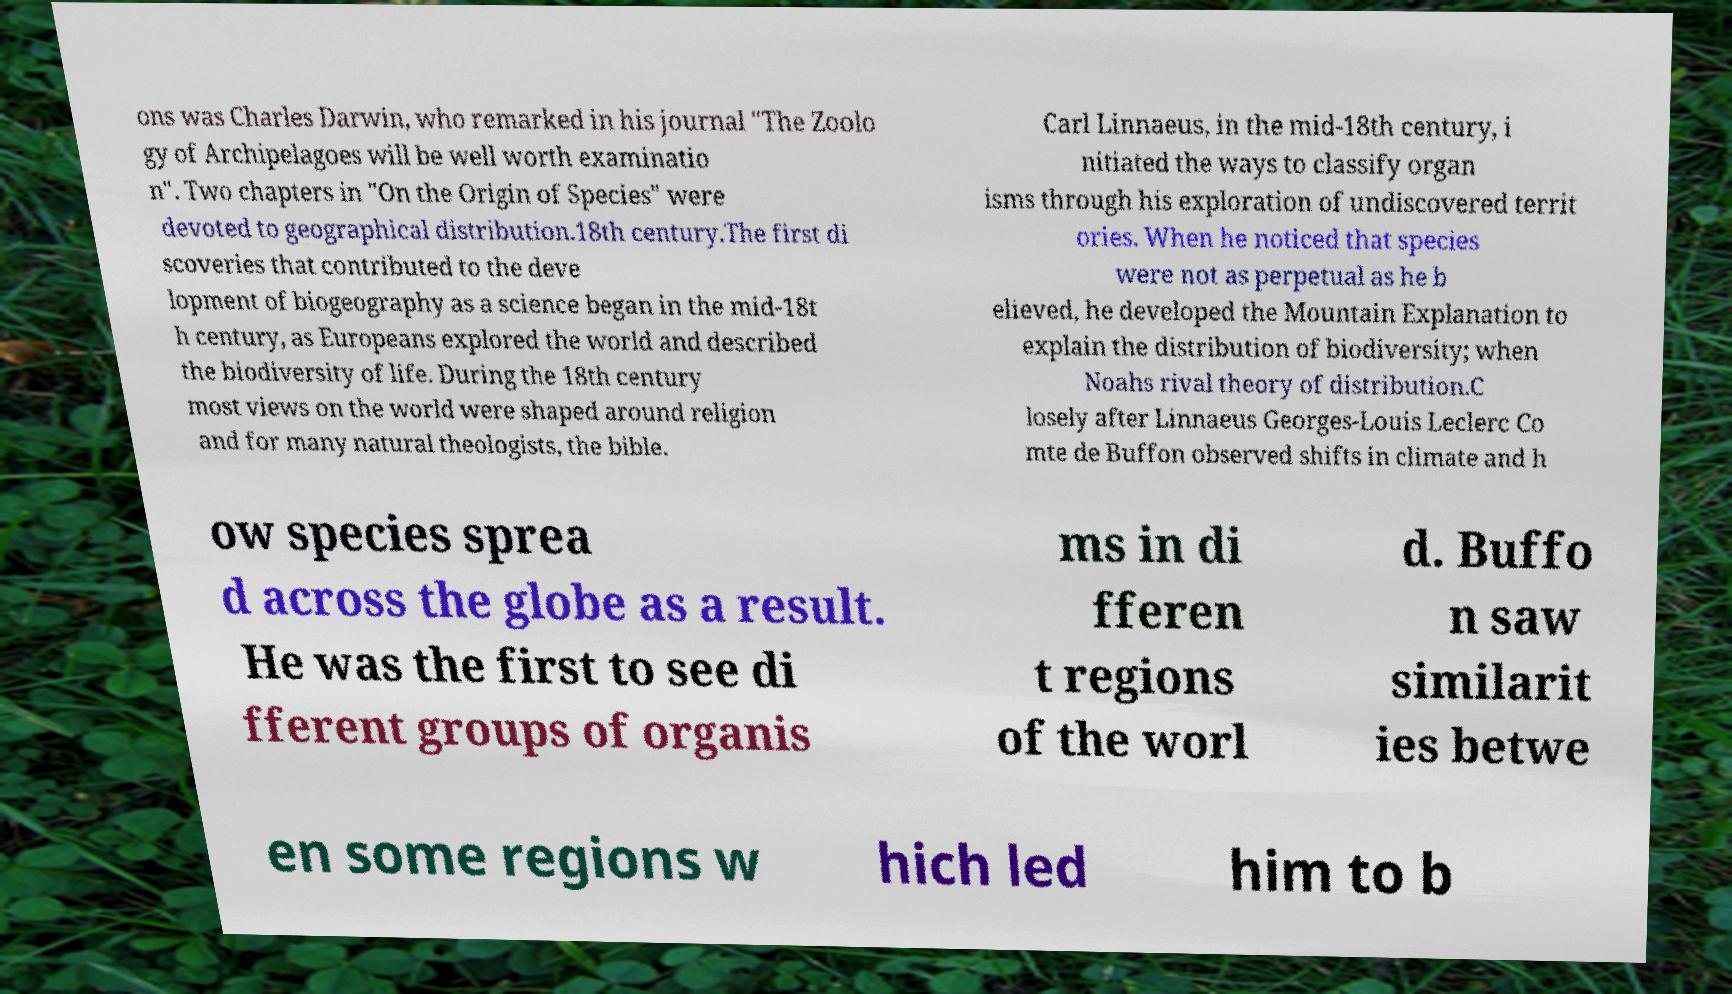Could you extract and type out the text from this image? ons was Charles Darwin, who remarked in his journal "The Zoolo gy of Archipelagoes will be well worth examinatio n". Two chapters in "On the Origin of Species" were devoted to geographical distribution.18th century.The first di scoveries that contributed to the deve lopment of biogeography as a science began in the mid-18t h century, as Europeans explored the world and described the biodiversity of life. During the 18th century most views on the world were shaped around religion and for many natural theologists, the bible. Carl Linnaeus, in the mid-18th century, i nitiated the ways to classify organ isms through his exploration of undiscovered territ ories. When he noticed that species were not as perpetual as he b elieved, he developed the Mountain Explanation to explain the distribution of biodiversity; when Noahs rival theory of distribution.C losely after Linnaeus Georges-Louis Leclerc Co mte de Buffon observed shifts in climate and h ow species sprea d across the globe as a result. He was the first to see di fferent groups of organis ms in di fferen t regions of the worl d. Buffo n saw similarit ies betwe en some regions w hich led him to b 